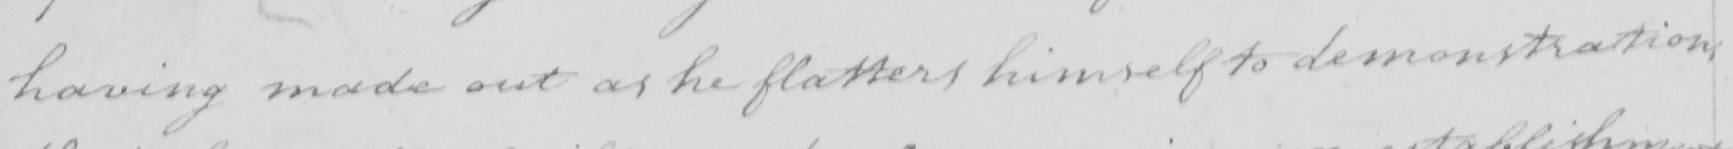What is written in this line of handwriting? having made out as he flatters himself to demonstration 